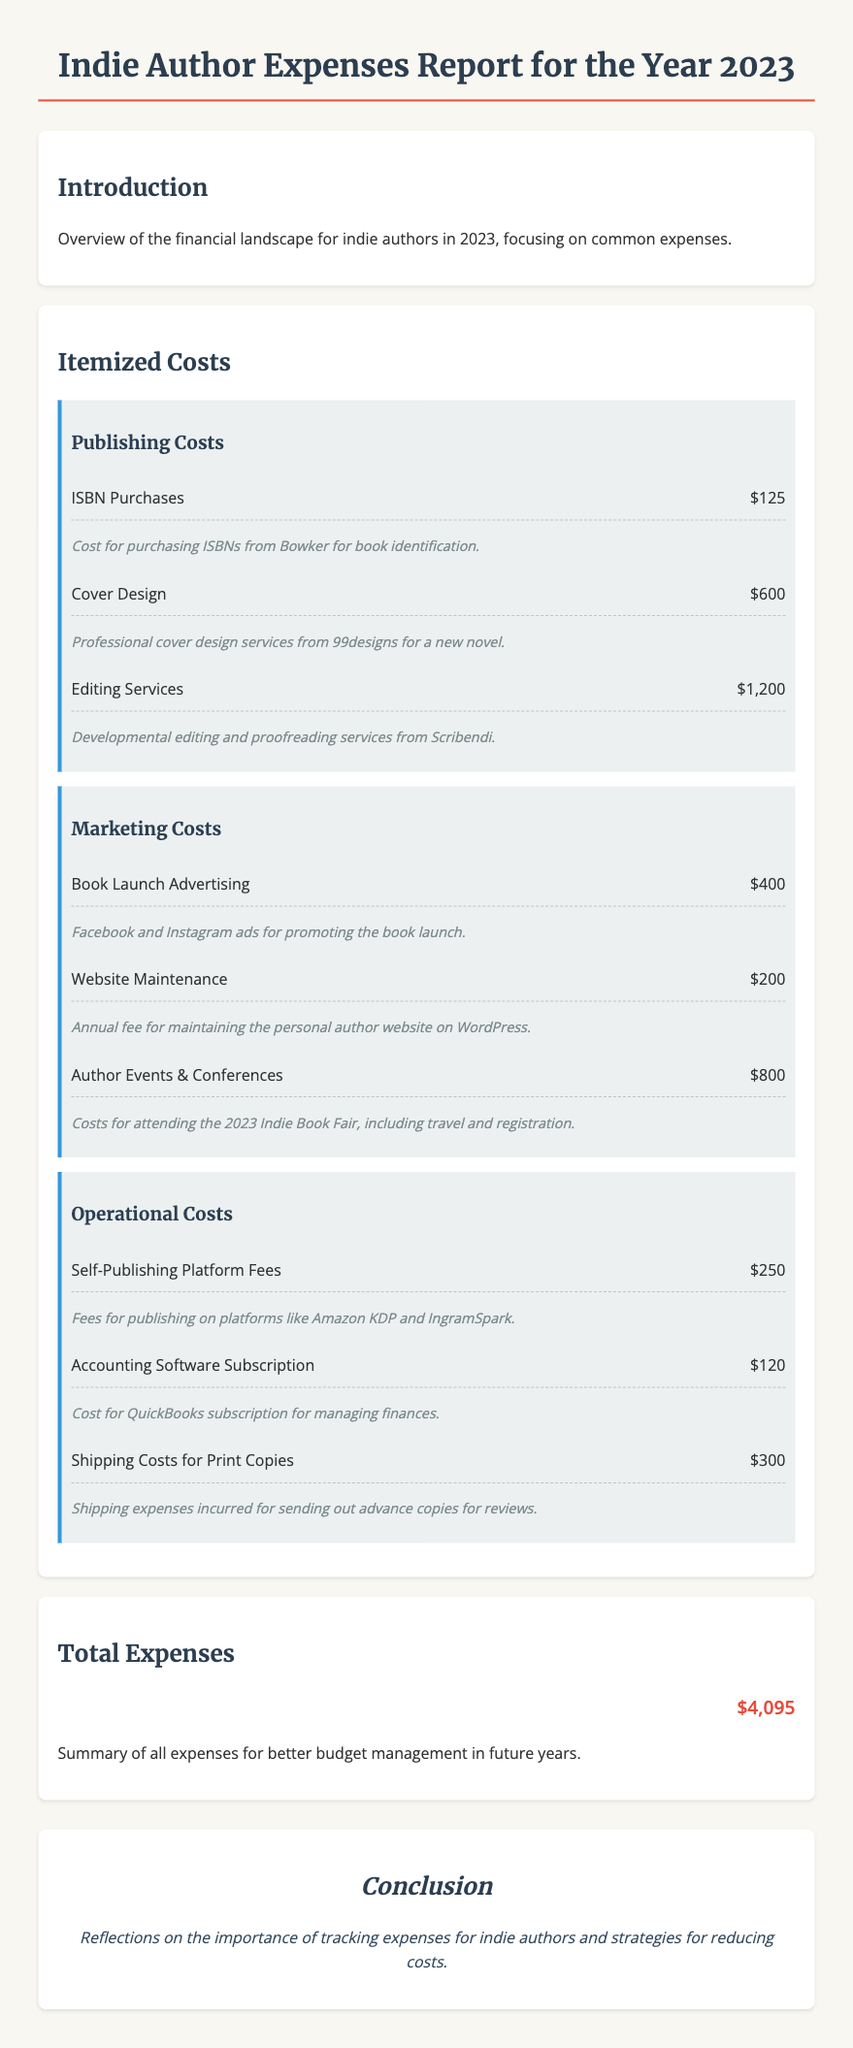What is the total amount spent on publishing costs? The total publishing costs can be calculated by adding the individual costs: $125 + $600 + $1,200 = $1,925.
Answer: $1,925 How much was spent on book launch advertising? The cost for book launch advertising is explicitly listed in the document as $400.
Answer: $400 What expenses were incurred for author events and conferences? The specific expenses for author events are noted as $800 for attending the 2023 Indie Book Fair.
Answer: $800 What is the cost for accounting software subscription? The document specifies that the accounting software subscription costs $120.
Answer: $120 What was the total expense for the year? The total expenses for the year are summed up at the end of the document as $4,095.
Answer: $4,095 How many different expense categories are listed? The document outlines three distinct expense categories: Publishing Costs, Marketing Costs, and Operational Costs.
Answer: 3 What is the expense on cover design? The expense related to cover design is stated as $600.
Answer: $600 Which expense is related to shipping costs? The document details that shipping costs for print copies amounted to $300.
Answer: $300 